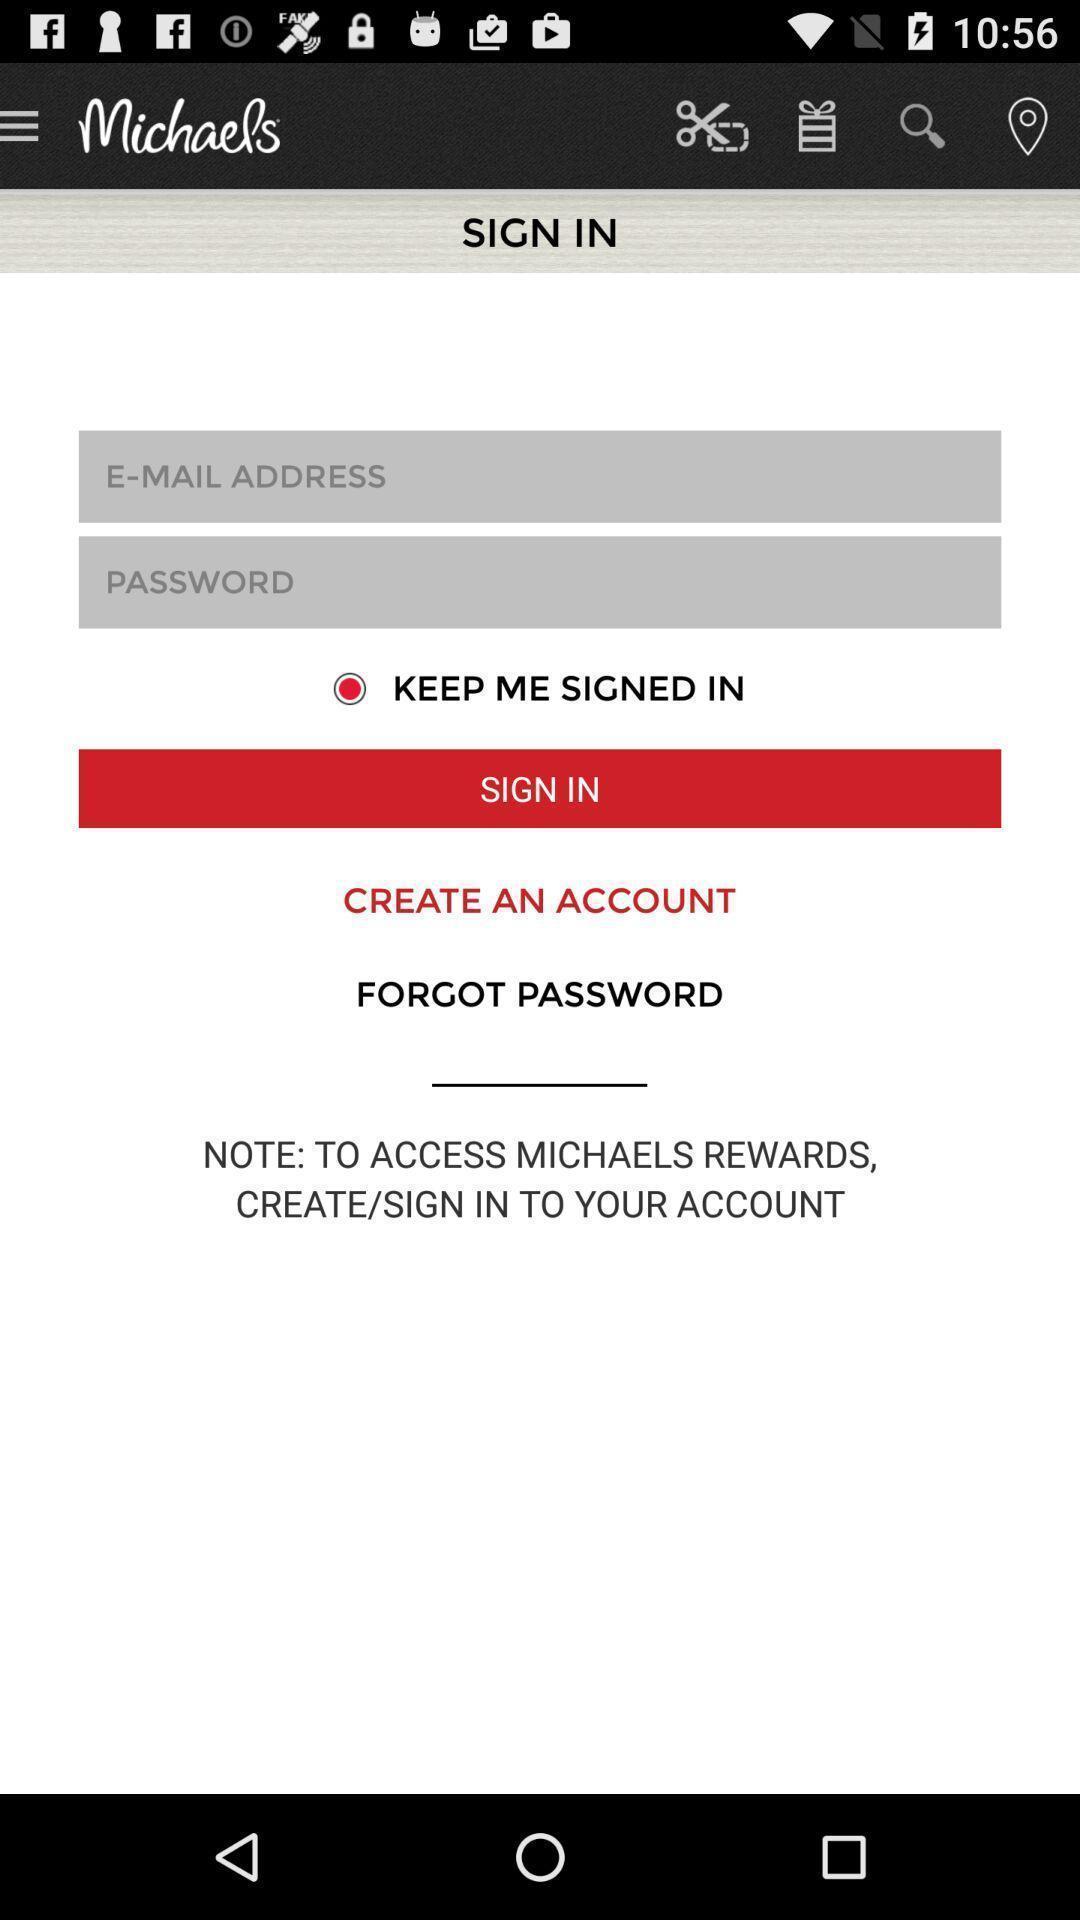Describe the content in this image. Sign in page of the app. 